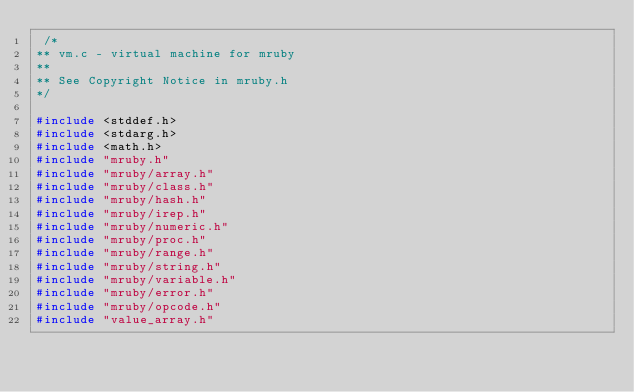<code> <loc_0><loc_0><loc_500><loc_500><_C_> /*
** vm.c - virtual machine for mruby
**
** See Copyright Notice in mruby.h
*/

#include <stddef.h>
#include <stdarg.h>
#include <math.h>
#include "mruby.h"
#include "mruby/array.h"
#include "mruby/class.h"
#include "mruby/hash.h"
#include "mruby/irep.h"
#include "mruby/numeric.h"
#include "mruby/proc.h"
#include "mruby/range.h"
#include "mruby/string.h"
#include "mruby/variable.h"
#include "mruby/error.h"
#include "mruby/opcode.h"
#include "value_array.h"</code> 